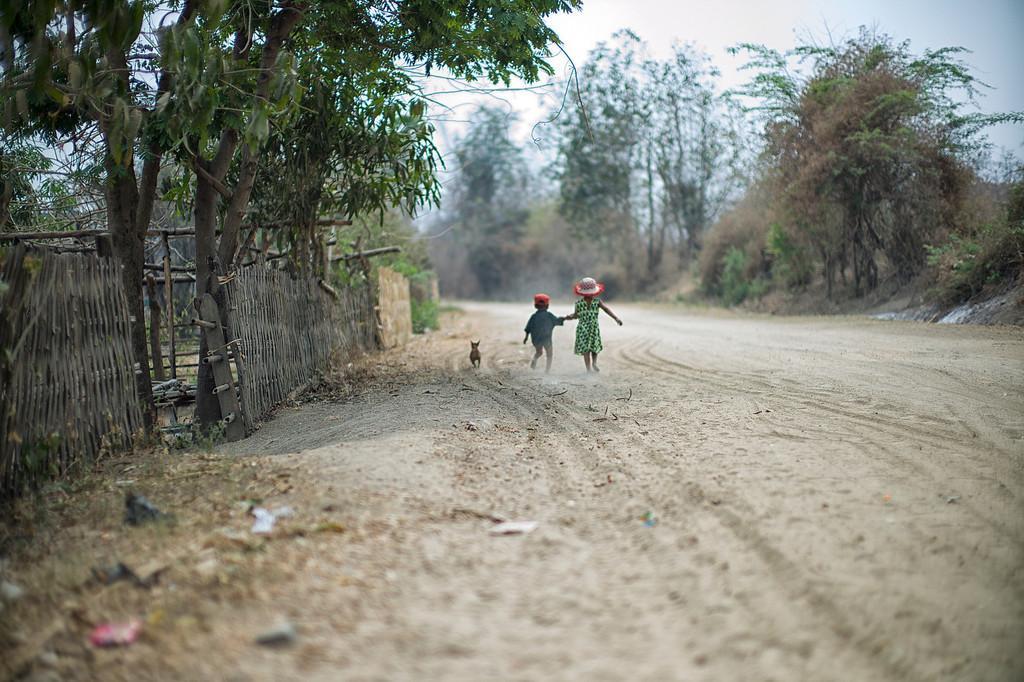How would you summarize this image in a sentence or two? In this image we can see two kids on the ground and an animal beside them and there are few trees, fence and the sky in the background. 